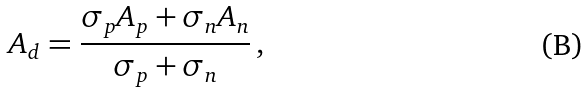Convert formula to latex. <formula><loc_0><loc_0><loc_500><loc_500>A _ { d } = \frac { \sigma _ { p } A _ { p } + \sigma _ { n } A _ { n } } { \sigma _ { p } + \sigma _ { n } } \, ,</formula> 